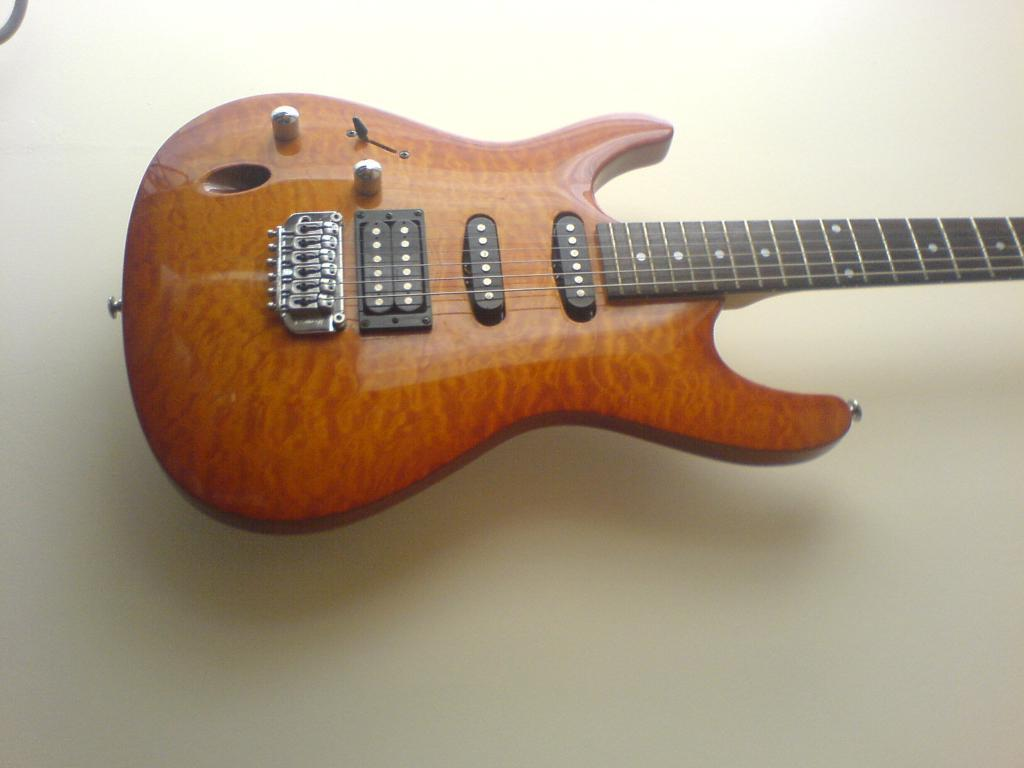What musical instrument is present in the image? There is a guitar in the image. How many strings does the guitar have? The guitar has six strings. What part of the guitar is used for tuning? The guitar has a head, which is used for tuning. What type of oatmeal is being served in the image? There is no oatmeal present in the image; it features a guitar with six strings and a head for tuning. Is there a scarecrow involved in a discussion with the guitar in the image? There is no scarecrow or discussion present in the image; it only features a guitar with six strings and a head for tuning. 